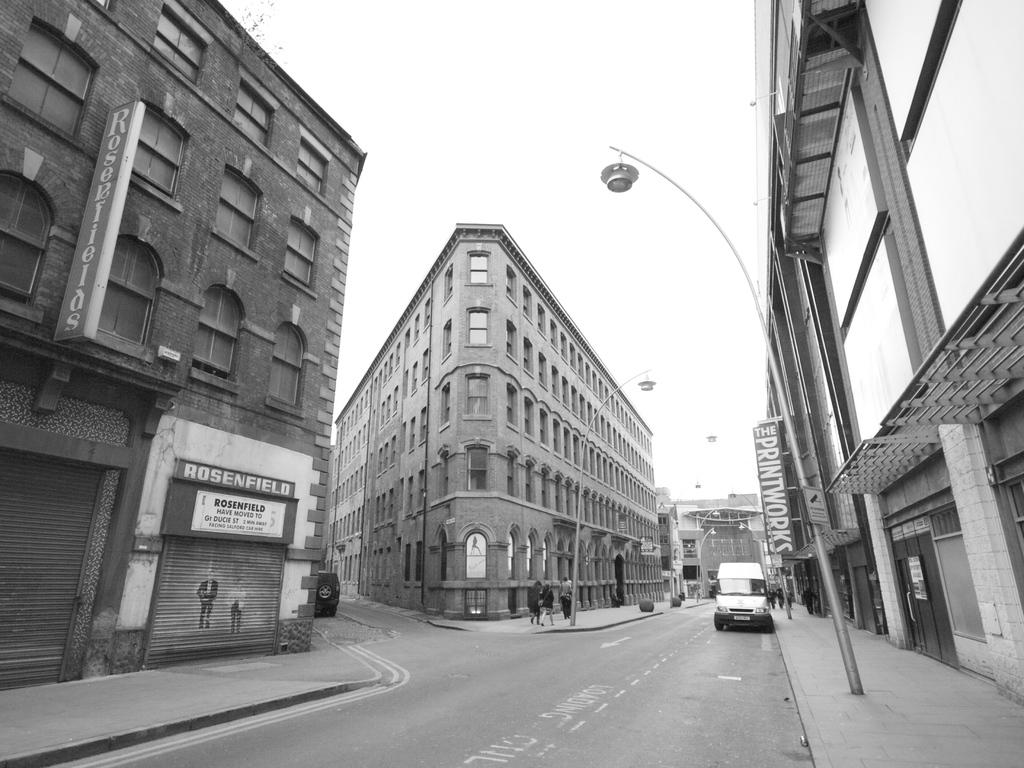<image>
Present a compact description of the photo's key features. A sign says that Rosenfield has moved to another location. 